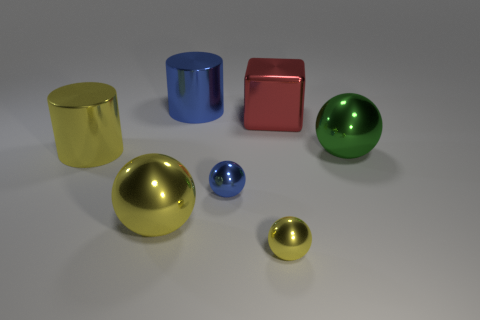Subtract all blue metal spheres. How many spheres are left? 3 Subtract all green spheres. How many spheres are left? 3 Subtract all brown cubes. How many yellow balls are left? 2 Subtract 1 balls. How many balls are left? 3 Add 1 green things. How many objects exist? 8 Subtract all cubes. How many objects are left? 6 Add 5 large green things. How many large green things are left? 6 Add 5 green matte cylinders. How many green matte cylinders exist? 5 Subtract 1 blue balls. How many objects are left? 6 Subtract all blue blocks. Subtract all red balls. How many blocks are left? 1 